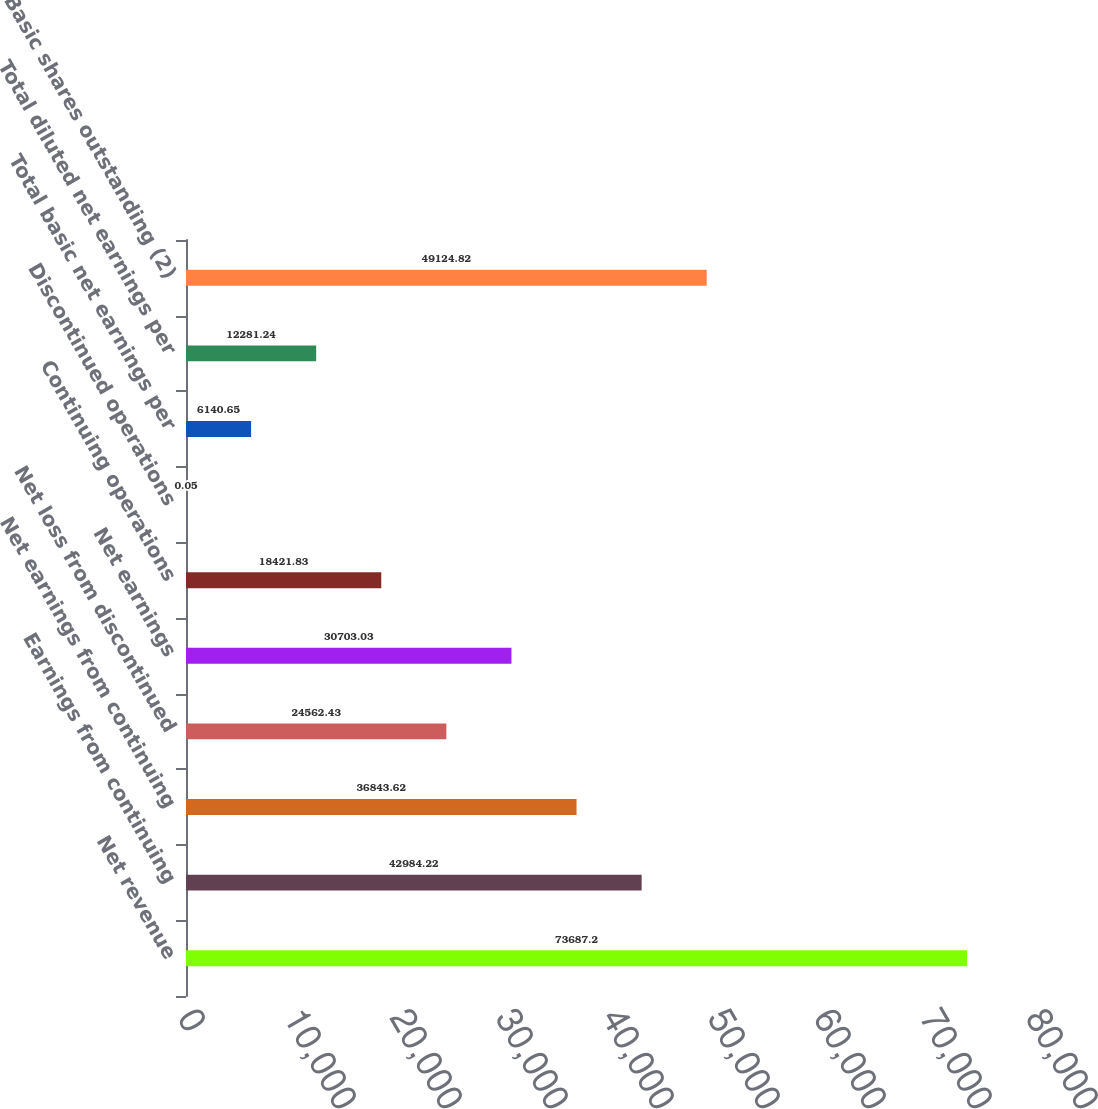<chart> <loc_0><loc_0><loc_500><loc_500><bar_chart><fcel>Net revenue<fcel>Earnings from continuing<fcel>Net earnings from continuing<fcel>Net loss from discontinued<fcel>Net earnings<fcel>Continuing operations<fcel>Discontinued operations<fcel>Total basic net earnings per<fcel>Total diluted net earnings per<fcel>Basic shares outstanding (2)<nl><fcel>73687.2<fcel>42984.2<fcel>36843.6<fcel>24562.4<fcel>30703<fcel>18421.8<fcel>0.05<fcel>6140.65<fcel>12281.2<fcel>49124.8<nl></chart> 